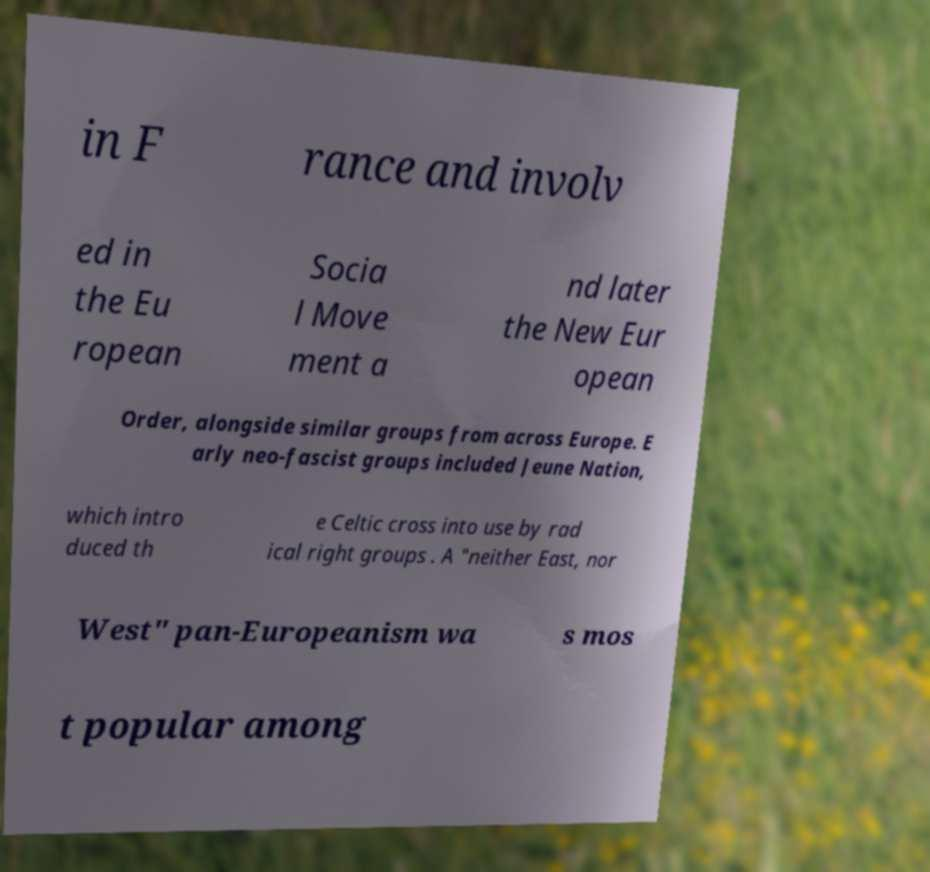Please read and relay the text visible in this image. What does it say? in F rance and involv ed in the Eu ropean Socia l Move ment a nd later the New Eur opean Order, alongside similar groups from across Europe. E arly neo-fascist groups included Jeune Nation, which intro duced th e Celtic cross into use by rad ical right groups . A "neither East, nor West" pan-Europeanism wa s mos t popular among 